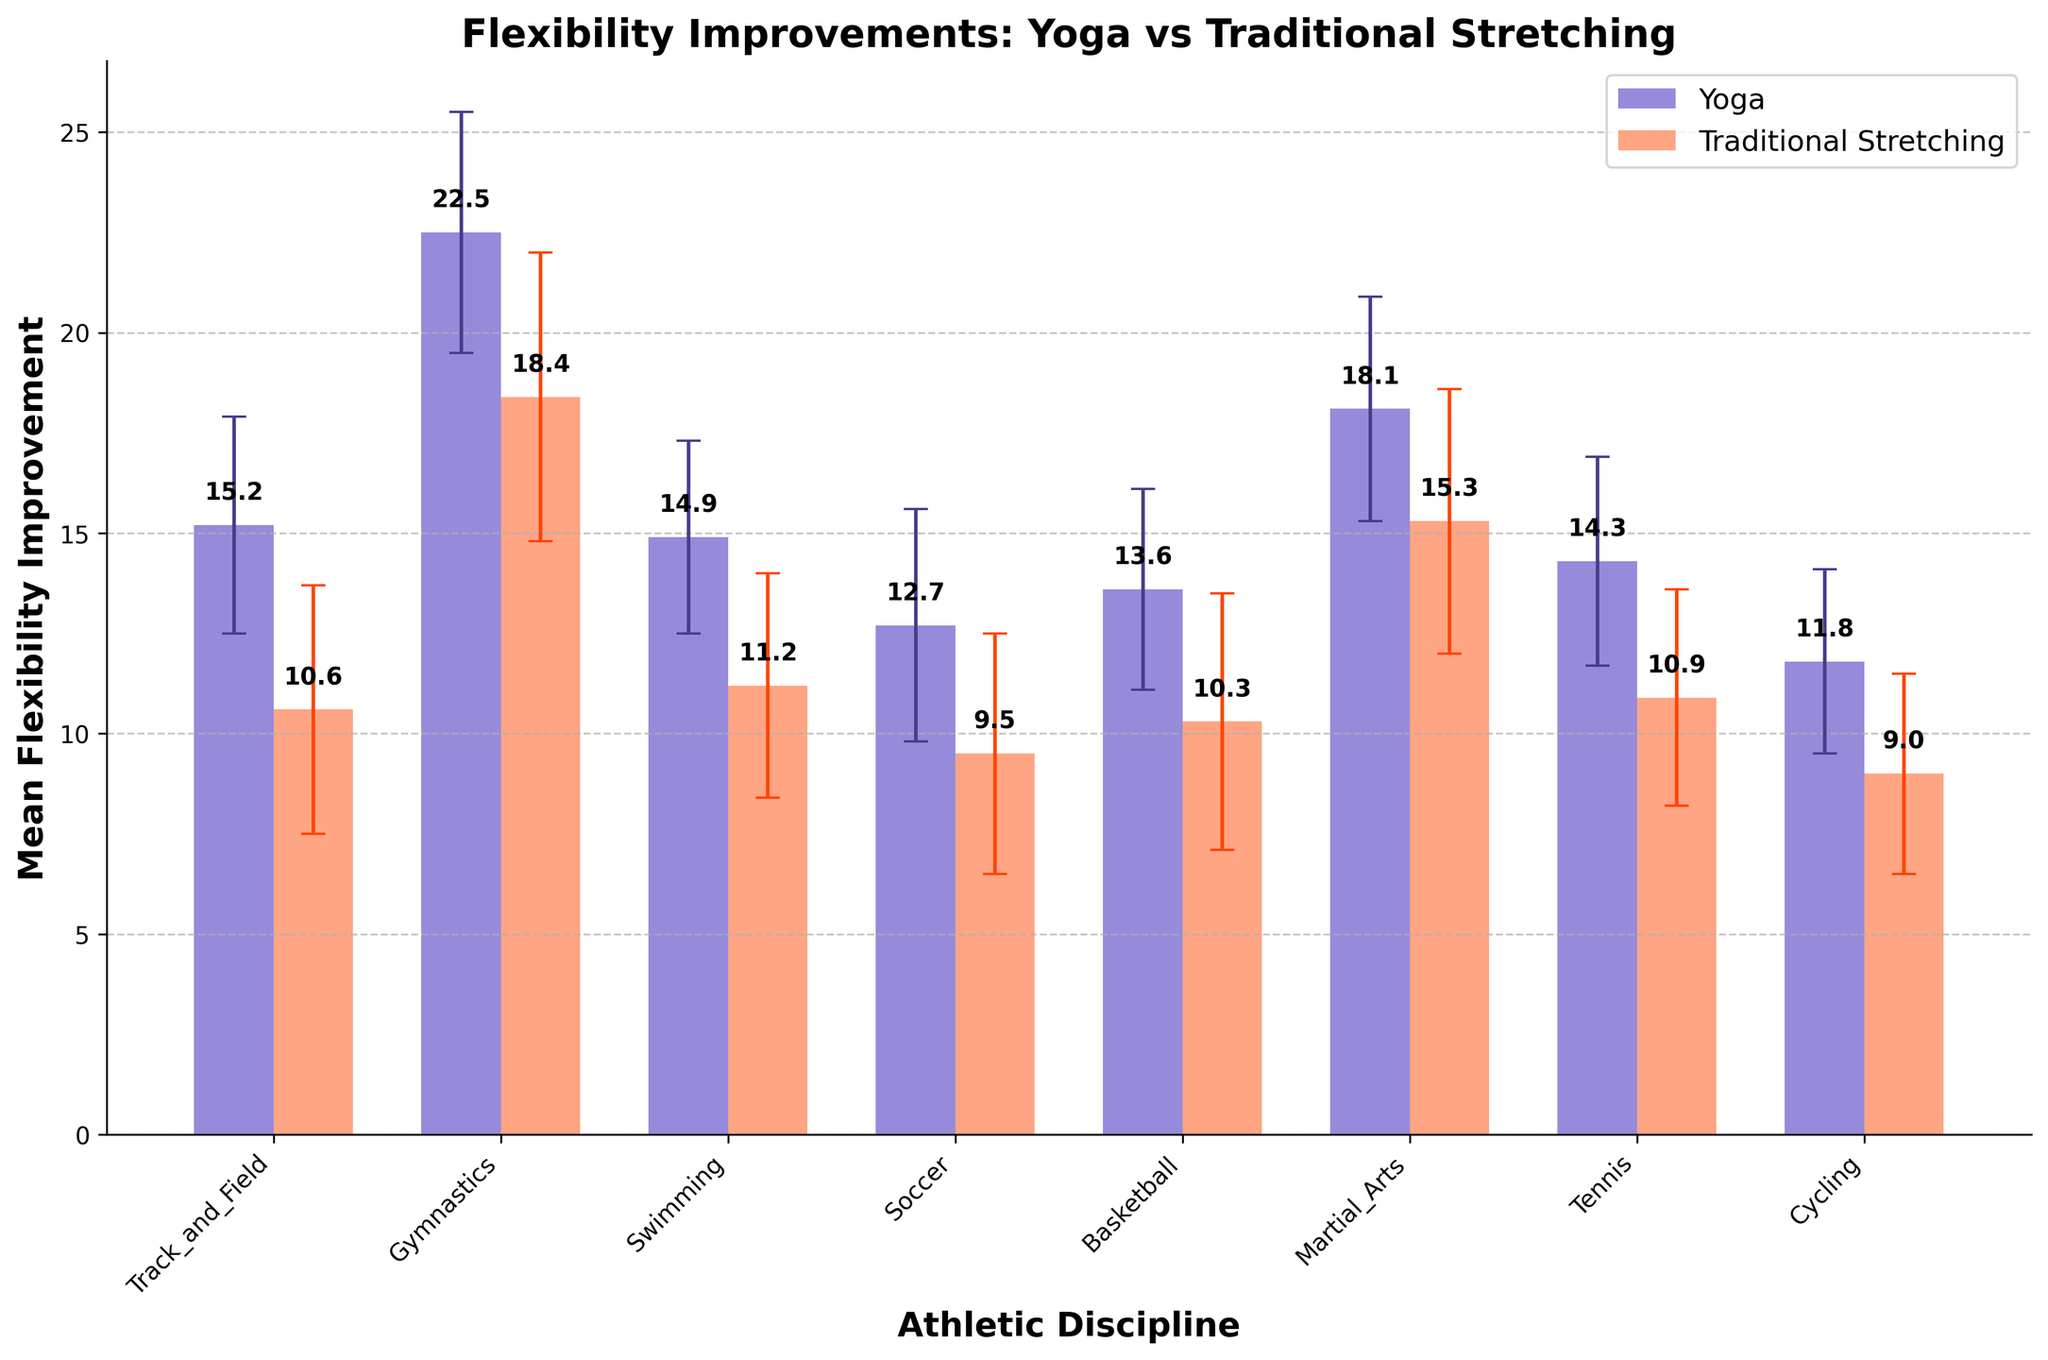What is the title of the figure? The title of the figure is displayed at the top center and it indicates the main subject of the plot, which contrasts two methods for flexibility improvements.
Answer: Flexibility Improvements: Yoga vs Traditional Stretching How many athletic disciplines are compared in the figure? The x-axis shows the labels for each athletic discipline. By counting the unique labels, we can determine the number of disciplines compared.
Answer: 7 Which method shows the highest mean flexibility improvement in Gymnastics? Look for the bar corresponding to Gymnastics and compare the two bars representing Yoga and Traditional Stretching. Check the height of the bars to determine which is higher.
Answer: Yoga What is the mean flexibility improvement for Basketball using Traditional Stretching? Locate the bar corresponding to Basketball for Traditional Stretching and read the value displayed above it.
Answer: 10.3 What is the difference in mean flexibility improvement between Yoga and Traditional Stretching for Track and Field athletes? Find the mean values for both Yoga and Traditional Stretching under Track and Field, then subtract the Traditional Stretching value from the Yoga value (15.2 - 10.6).
Answer: 4.6 Which method had a lower standard deviation in Swimming? Check the error bars for Swimming. The bar with the smaller range indicates the method with a lower standard deviation. Compare the error bars for Yoga and Traditional Stretching.
Answer: Yoga How does the mean flexibility improvement for Martial Arts compare between Yoga and Traditional Stretching? Compare the heights of the bars for Yoga and Traditional Stretching under Martial Arts.
Answer: Yoga has a higher mean flexibility improvement than Traditional Stretching What is the average mean flexibility improvement for Tennis across both methods? Find the mean values for Yoga and Traditional Stretching under Tennis and calculate the average: (14.3 + 10.9) / 2.
Answer: 12.6 Which athletic discipline shows the smallest standard deviation for both methods? Examine the error bars for each method across all disciplines and identify the smallest one.
Answer: Cycling (Yoga: 2.3) In which athletic discipline is the difference between standard deviations of the two methods the greatest? Calculate the absolute differences between the standard deviations for each discipline and compare. The greatest difference is in Gymnastics (3.6 - 3.0).
Answer: Gymnastics 